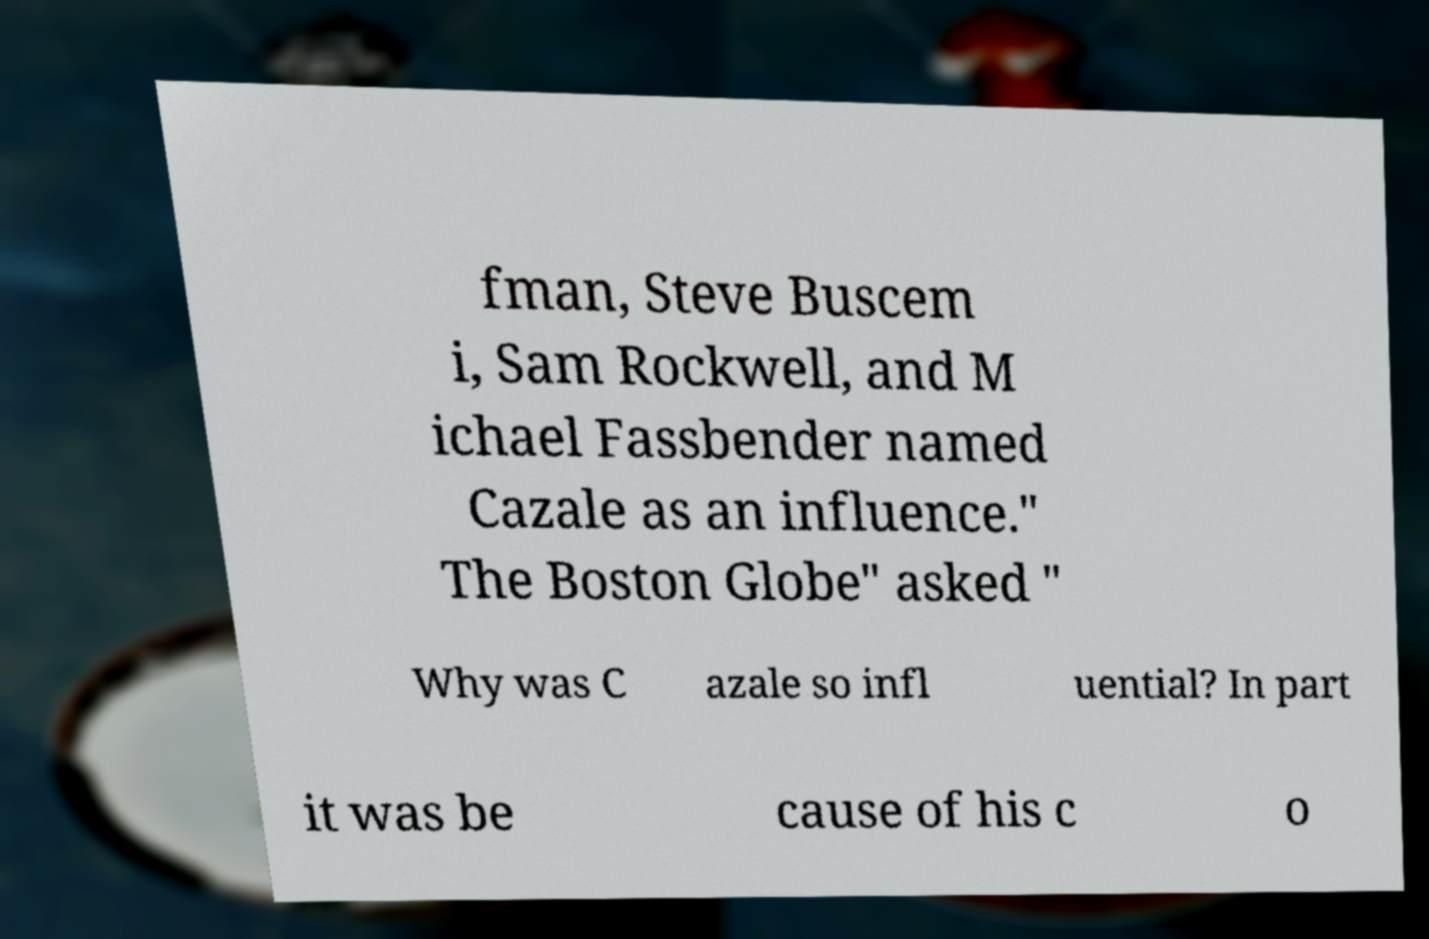What messages or text are displayed in this image? I need them in a readable, typed format. fman, Steve Buscem i, Sam Rockwell, and M ichael Fassbender named Cazale as an influence." The Boston Globe" asked " Why was C azale so infl uential? In part it was be cause of his c o 